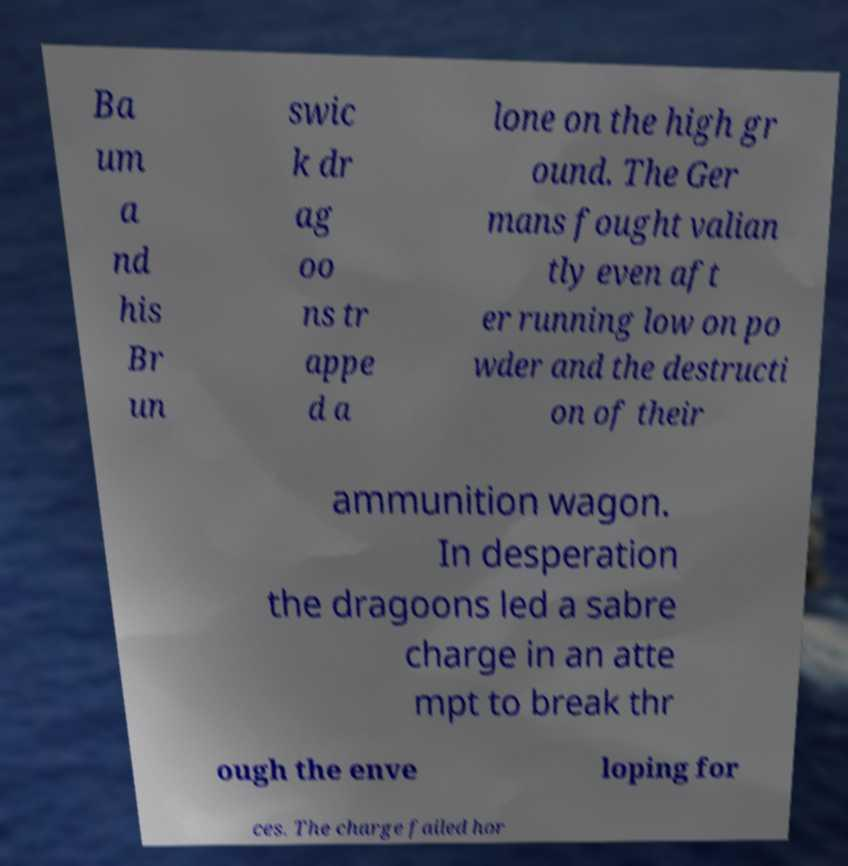Please read and relay the text visible in this image. What does it say? Ba um a nd his Br un swic k dr ag oo ns tr appe d a lone on the high gr ound. The Ger mans fought valian tly even aft er running low on po wder and the destructi on of their ammunition wagon. In desperation the dragoons led a sabre charge in an atte mpt to break thr ough the enve loping for ces. The charge failed hor 